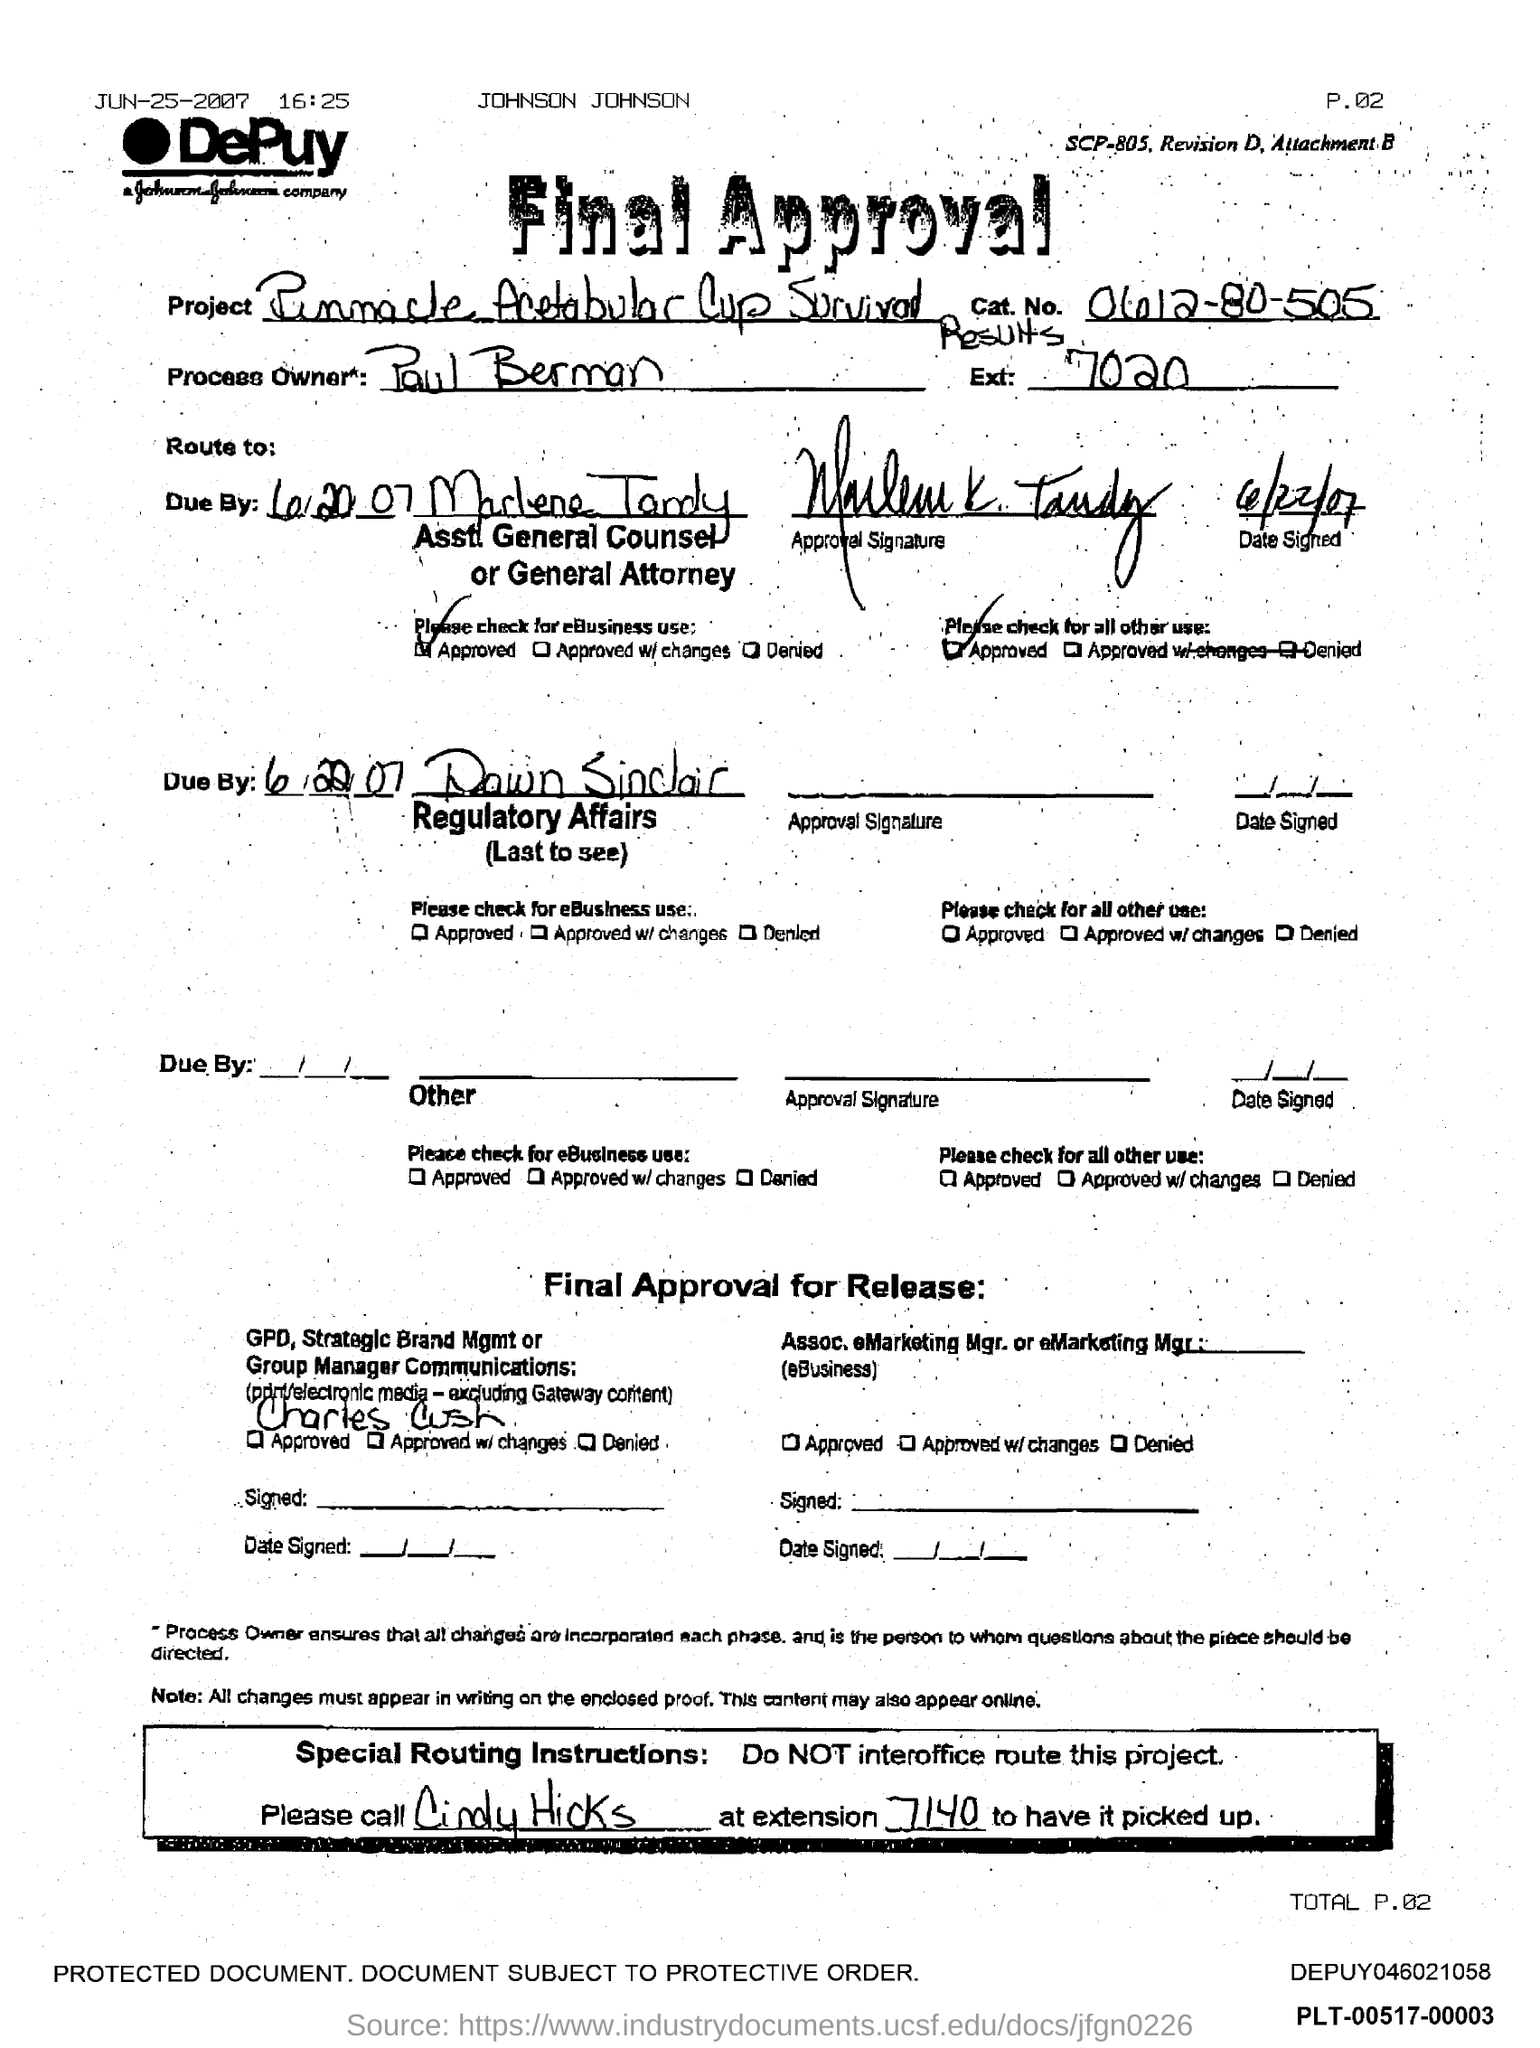Specify some key components in this picture. The Process Owner is Paul Berman. What is the Cat.No? 0612-80-505.." is a question asking for information about a specific identifier number, specifically a Cat.No. 